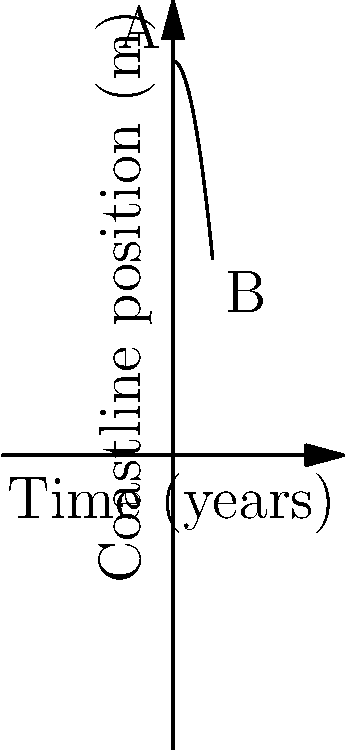As a concerned Sandbanks resident, you've been monitoring the coastline erosion over the past decade. The graph shows the position of the coastline relative to a fixed point over 10 years. If the coastline position (in meters) is given by the function $f(t) = 100 - 0.5t^2$, where $t$ is time in years, what is the rate of coastline erosion (in meters per year) after 5 years? To find the rate of coastline erosion after 5 years, we need to calculate the derivative of the function $f(t)$ at $t=5$. This will give us the instantaneous rate of change at that point.

Step 1: Find the derivative of $f(t)$.
$f(t) = 100 - 0.5t^2$
$f'(t) = -t$

Step 2: Evaluate the derivative at $t=5$.
$f'(5) = -5$

The negative sign indicates that the coastline is receding (moving inland).

Step 3: Interpret the result.
The rate of erosion after 5 years is 5 meters per year.
Answer: 5 meters per year 